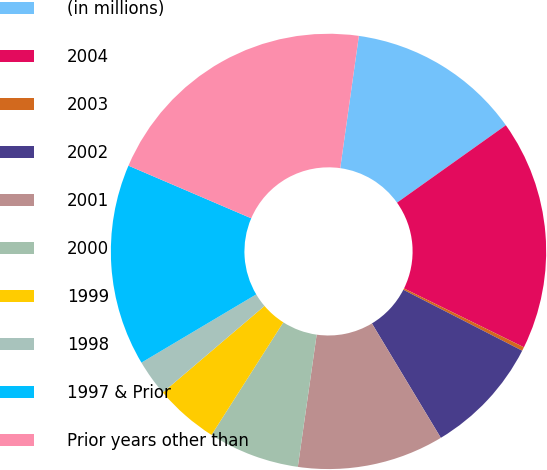Convert chart. <chart><loc_0><loc_0><loc_500><loc_500><pie_chart><fcel>(in millions)<fcel>2004<fcel>2003<fcel>2002<fcel>2001<fcel>2000<fcel>1999<fcel>1998<fcel>1997 & Prior<fcel>Prior years other than<nl><fcel>12.93%<fcel>17.1%<fcel>0.28%<fcel>8.83%<fcel>10.88%<fcel>6.78%<fcel>4.74%<fcel>2.69%<fcel>14.98%<fcel>20.78%<nl></chart> 